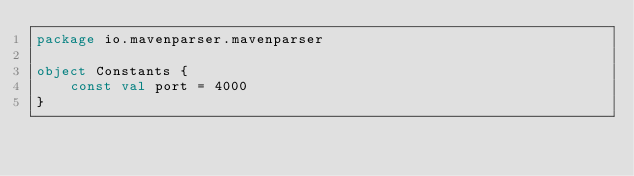<code> <loc_0><loc_0><loc_500><loc_500><_Kotlin_>package io.mavenparser.mavenparser

object Constants {
    const val port = 4000
}</code> 